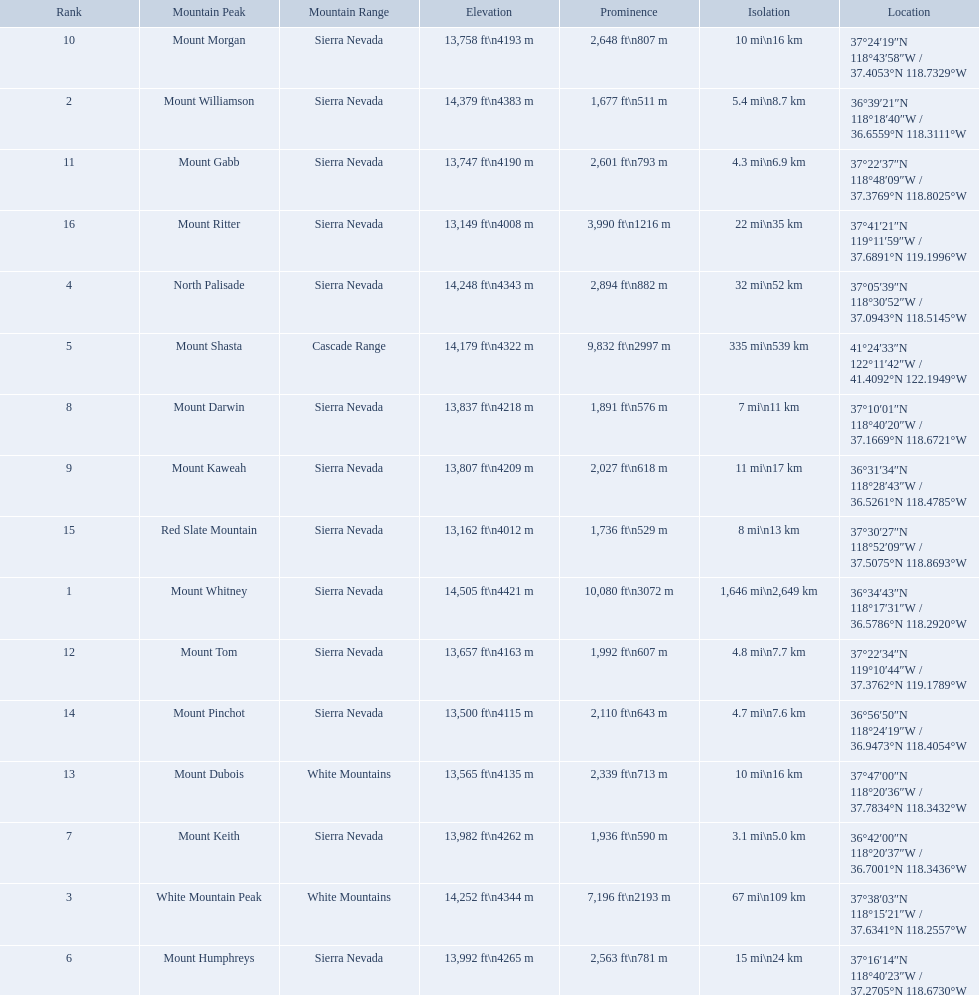What are all of the mountain peaks? Mount Whitney, Mount Williamson, White Mountain Peak, North Palisade, Mount Shasta, Mount Humphreys, Mount Keith, Mount Darwin, Mount Kaweah, Mount Morgan, Mount Gabb, Mount Tom, Mount Dubois, Mount Pinchot, Red Slate Mountain, Mount Ritter. In what ranges are they? Sierra Nevada, Sierra Nevada, White Mountains, Sierra Nevada, Cascade Range, Sierra Nevada, Sierra Nevada, Sierra Nevada, Sierra Nevada, Sierra Nevada, Sierra Nevada, Sierra Nevada, White Mountains, Sierra Nevada, Sierra Nevada, Sierra Nevada. Which peak is in the cascade range? Mount Shasta. What mountain peak is listed for the sierra nevada mountain range? Mount Whitney. What mountain peak has an elevation of 14,379ft? Mount Williamson. Which mountain is listed for the cascade range? Mount Shasta. 